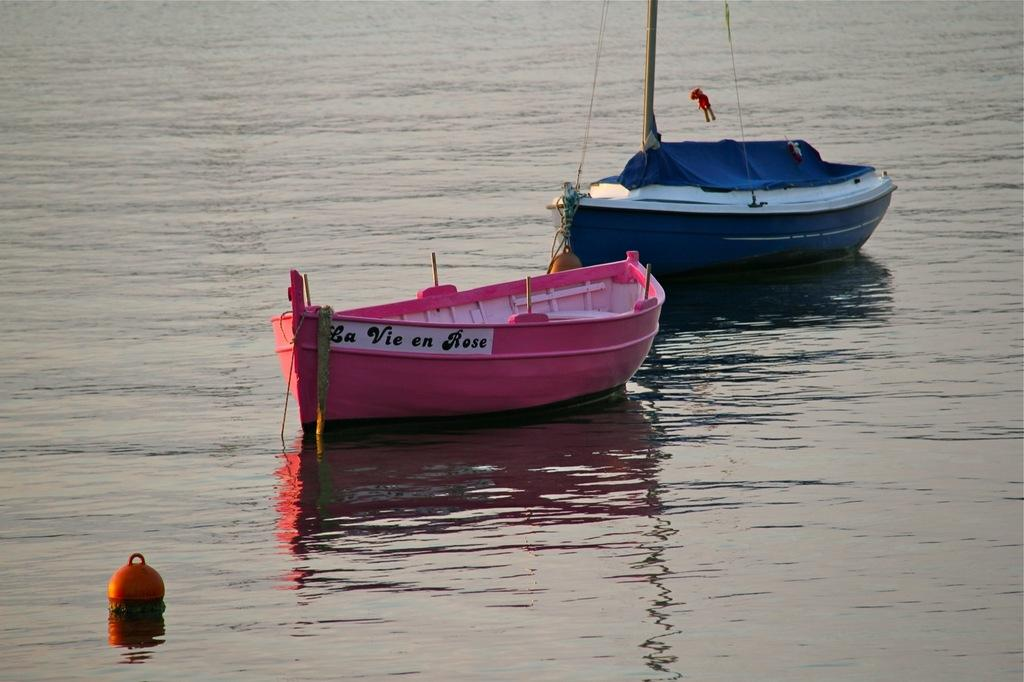How many boats are in the image? There are two boats in the image. Where are the boats located? The boats are on the water. Can you describe the object in the left corner of the image? Unfortunately, the facts provided do not give any information about the object in the left corner. What is visible in the background of the image? There is a lake in the background of the image. What is the lake filled with? The lake contains water. What is the income of the person who owns the boats in the image? There is no information about the income of the person who owns the boats in the image. What shape is the calculator on the boat in the image? There is no calculator present in the image. 